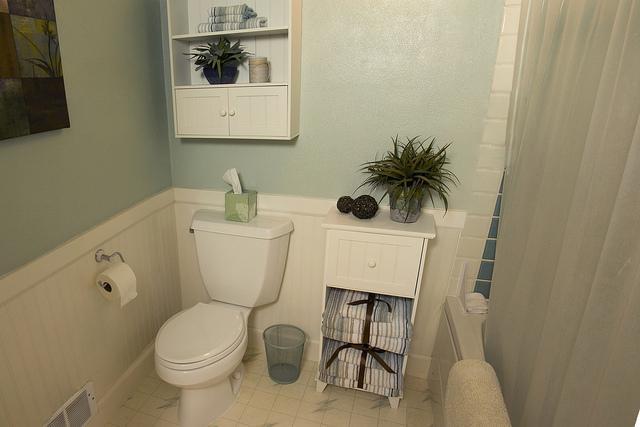How many plants are there?
Give a very brief answer. 2. How many people are riding the bike farthest to the left?
Give a very brief answer. 0. 